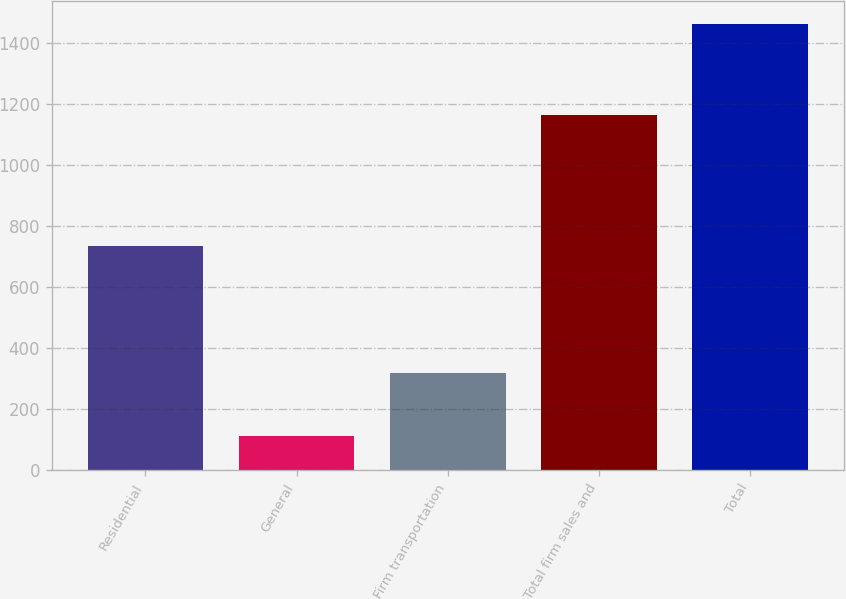Convert chart. <chart><loc_0><loc_0><loc_500><loc_500><bar_chart><fcel>Residential<fcel>General<fcel>Firm transportation<fcel>Total firm sales and<fcel>Total<nl><fcel>733<fcel>112<fcel>318<fcel>1163<fcel>1463<nl></chart> 